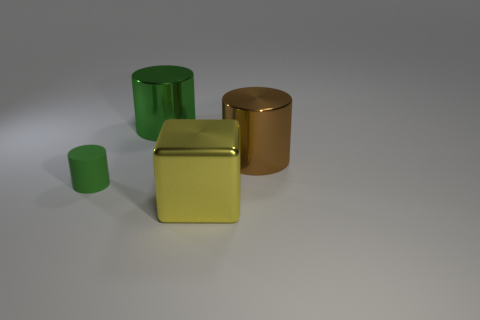Subtract all metal cylinders. How many cylinders are left? 1 Subtract all green cubes. How many green cylinders are left? 2 Add 2 large green matte things. How many objects exist? 6 Subtract all brown cylinders. How many cylinders are left? 2 Subtract all cylinders. How many objects are left? 1 Subtract 0 gray cylinders. How many objects are left? 4 Subtract all red blocks. Subtract all gray spheres. How many blocks are left? 1 Subtract all blue objects. Subtract all small cylinders. How many objects are left? 3 Add 1 large cubes. How many large cubes are left? 2 Add 2 green things. How many green things exist? 4 